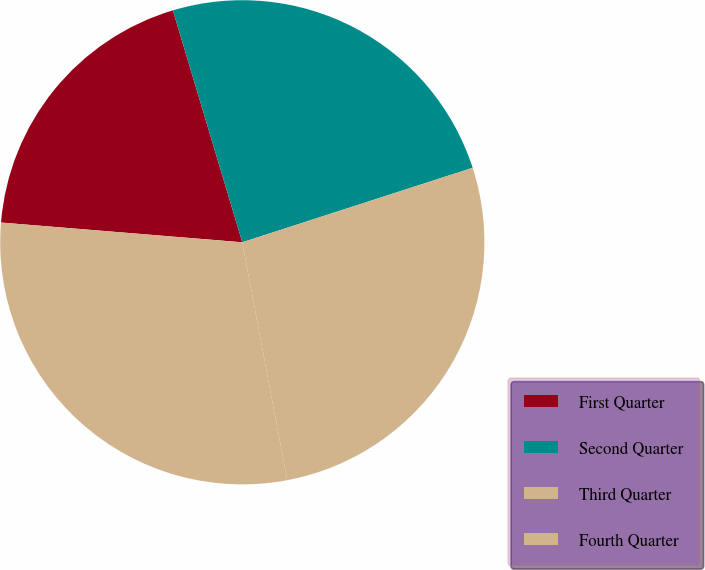Convert chart to OTSL. <chart><loc_0><loc_0><loc_500><loc_500><pie_chart><fcel>First Quarter<fcel>Second Quarter<fcel>Third Quarter<fcel>Fourth Quarter<nl><fcel>19.07%<fcel>24.65%<fcel>27.01%<fcel>29.27%<nl></chart> 